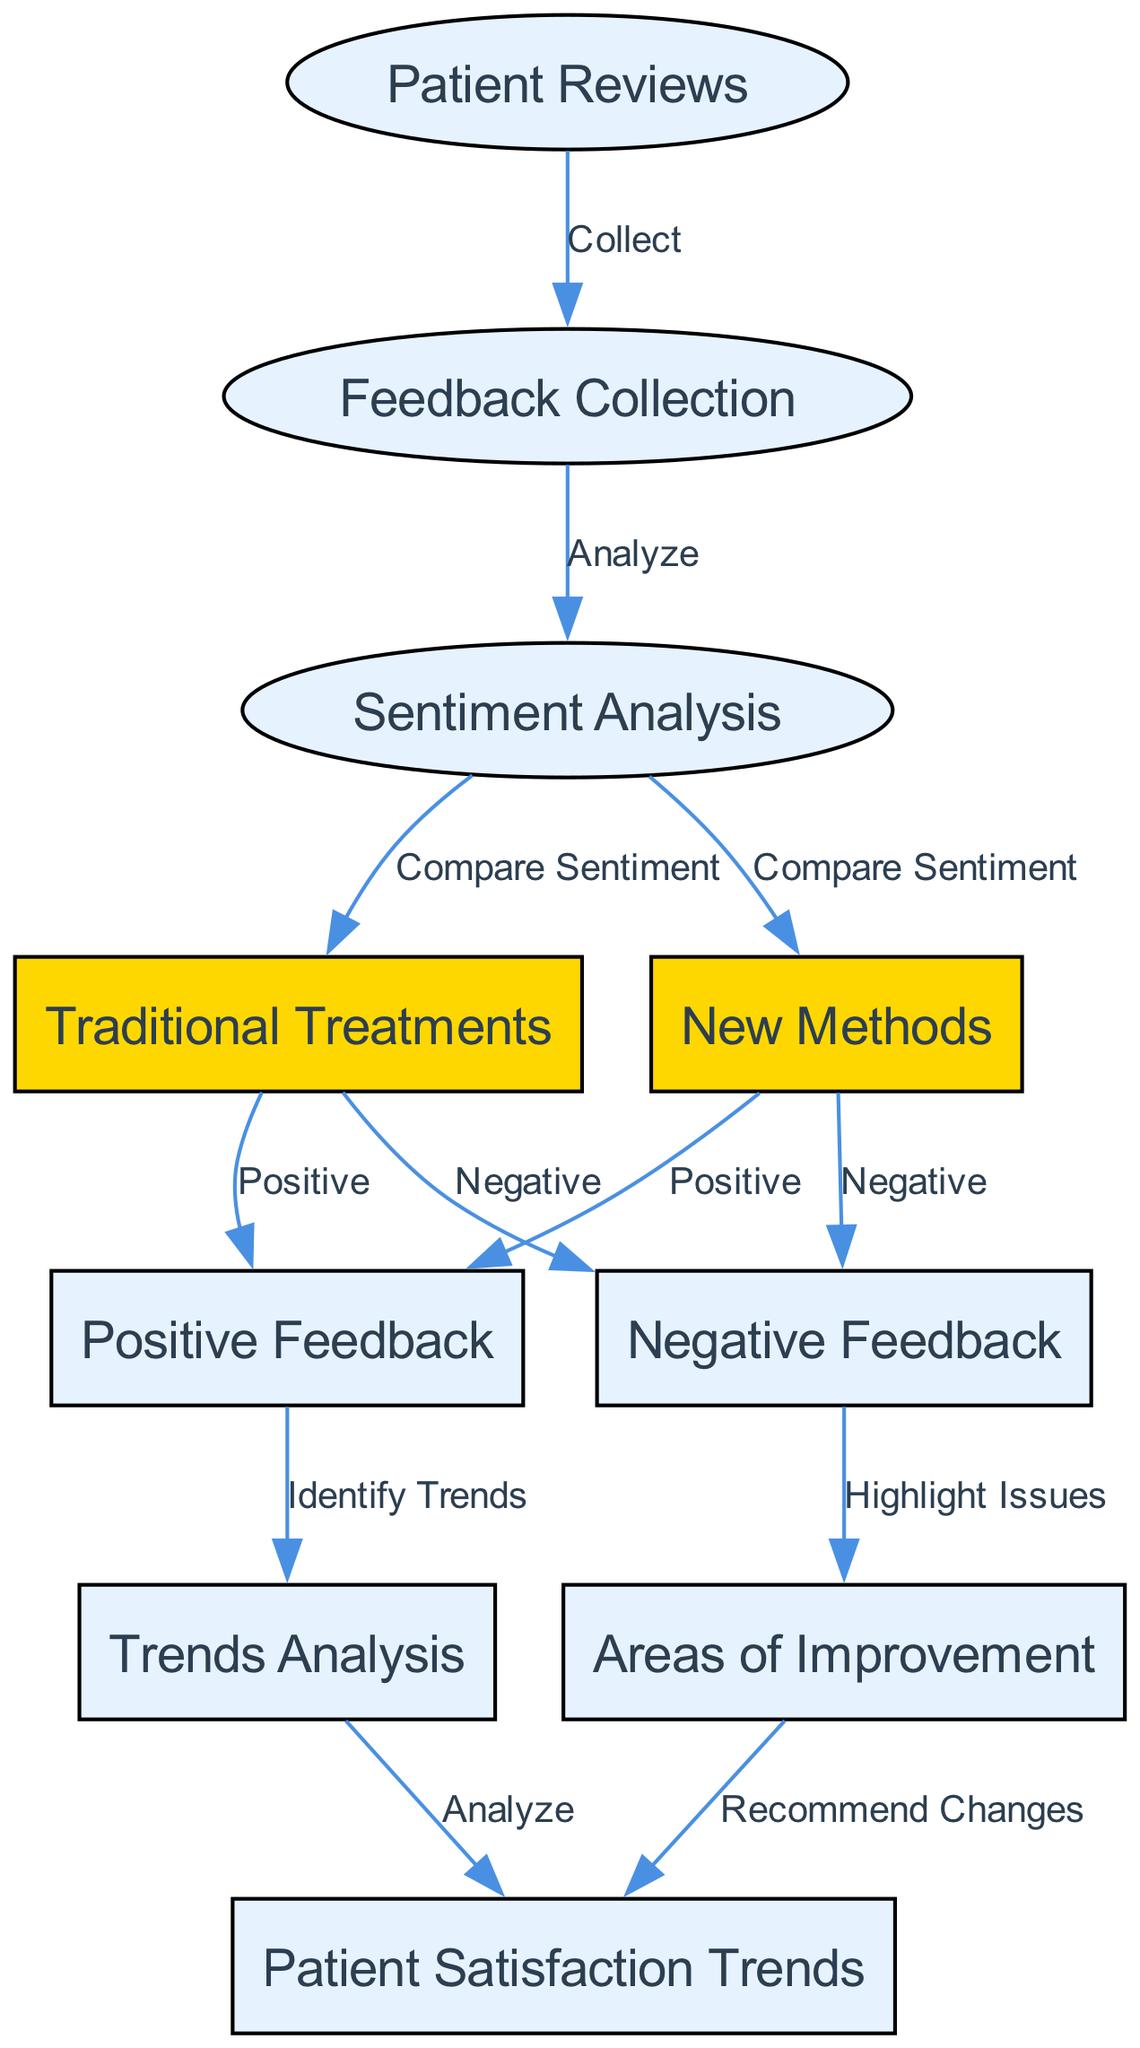What are the two main methods compared in the sentiment analysis? The diagram includes two nodes labeled "Traditional Treatments" and "New Methods," which represent the primary methods being compared for patient sentiment.
Answer: Traditional Treatments, New Methods How many nodes are in the diagram? By counting the nodes listed, there are a total of 10 nodes depicted in the diagram.
Answer: 10 What type of feedback is identified as positive for both traditional and new methods? The node labeled "Positive Feedback" connects from both the "Traditional Treatments" and "New Methods," indicating that both methods receive positive feedback.
Answer: Positive Feedback Which node highlights the issues based on negative feedback? The node labeled "Areas of Improvement" is connected to the node "Negative Feedback," indicating that it highlights issues arising from negative feedback.
Answer: Areas of Improvement What action is taken after identifying trends from positive feedback? The node "Identify Trends" is followed by the node "Analyze," indicating that trends identified lead to further analysis.
Answer: Analyze What does the sentiment analysis compare? The sentiment analysis compares the feedback regarding "Traditional Treatments" and "New Methods" as indicated by their connections to the "Sentiment Analysis" node.
Answer: Traditional Treatments, New Methods How does negative feedback influence patient satisfaction trends? Negative feedback is connected to the "Highlight Issues" node, which subsequently influences the "Patient Satisfaction Trends" by leading to recommendations for changes.
Answer: Highlight Issues What is the main purpose of the "Feedback Collection" node? The "Feedback Collection" node serves to collect patient reviews, as indicated by the directed edge leading from "Patient Reviews" to "Feedback Collection."
Answer: Collect What analysis follows the sentiment comparison of the methods? Following the sentiment comparisons from traditional and new methods, the next analysis step is to identify trends related to positive feedback.
Answer: Identify Trends 